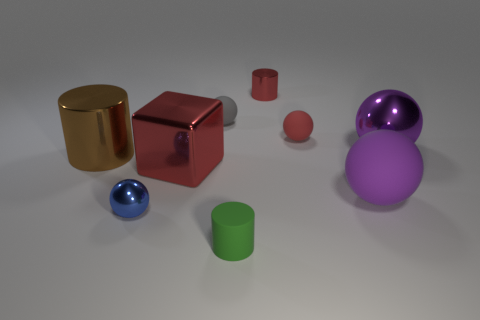There is a small gray object; is its shape the same as the big thing in front of the big cube?
Provide a short and direct response. Yes. What is the material of the small cylinder behind the red object on the right side of the small metal object that is behind the metal cube?
Make the answer very short. Metal. How many other objects are there of the same size as the red metallic cube?
Make the answer very short. 3. Is the color of the big metallic ball the same as the matte cylinder?
Offer a terse response. No. There is a small metallic object that is in front of the metallic ball that is behind the big red object; how many rubber things are in front of it?
Offer a terse response. 1. What material is the cylinder that is on the left side of the metal ball that is to the left of the small gray sphere made of?
Your answer should be compact. Metal. Is there a gray shiny object of the same shape as the gray rubber thing?
Keep it short and to the point. No. The shiny block that is the same size as the purple matte object is what color?
Ensure brevity in your answer.  Red. How many things are red things behind the tiny gray matte object or small metal objects that are behind the brown metal object?
Offer a terse response. 1. How many things are small cylinders or big yellow metallic cylinders?
Give a very brief answer. 2. 